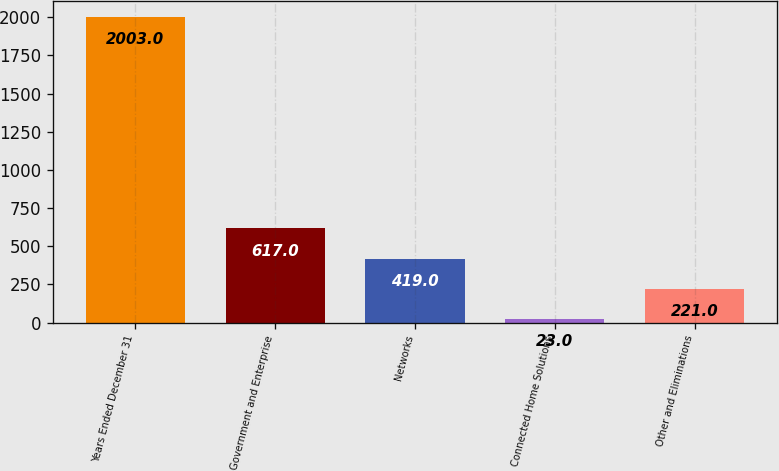Convert chart. <chart><loc_0><loc_0><loc_500><loc_500><bar_chart><fcel>Years Ended December 31<fcel>Government and Enterprise<fcel>Networks<fcel>Connected Home Solutions<fcel>Other and Eliminations<nl><fcel>2003<fcel>617<fcel>419<fcel>23<fcel>221<nl></chart> 